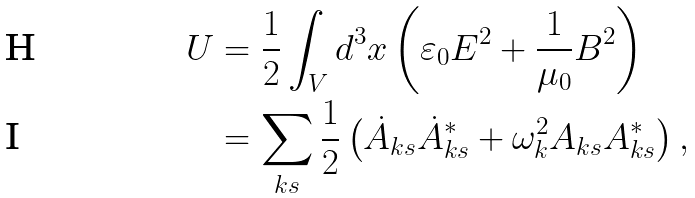<formula> <loc_0><loc_0><loc_500><loc_500>U & = \frac { 1 } { 2 } \int _ { V } d ^ { 3 } x \left ( \varepsilon _ { 0 } E ^ { 2 } + \frac { 1 } { \mu _ { 0 } } B ^ { 2 } \right ) \\ & = \sum _ { k s } \frac { 1 } { 2 } \left ( \dot { A } _ { k s } \dot { A } _ { k s } ^ { * } + \omega _ { k } ^ { 2 } A _ { k s } A _ { k s } ^ { * } \right ) ,</formula> 